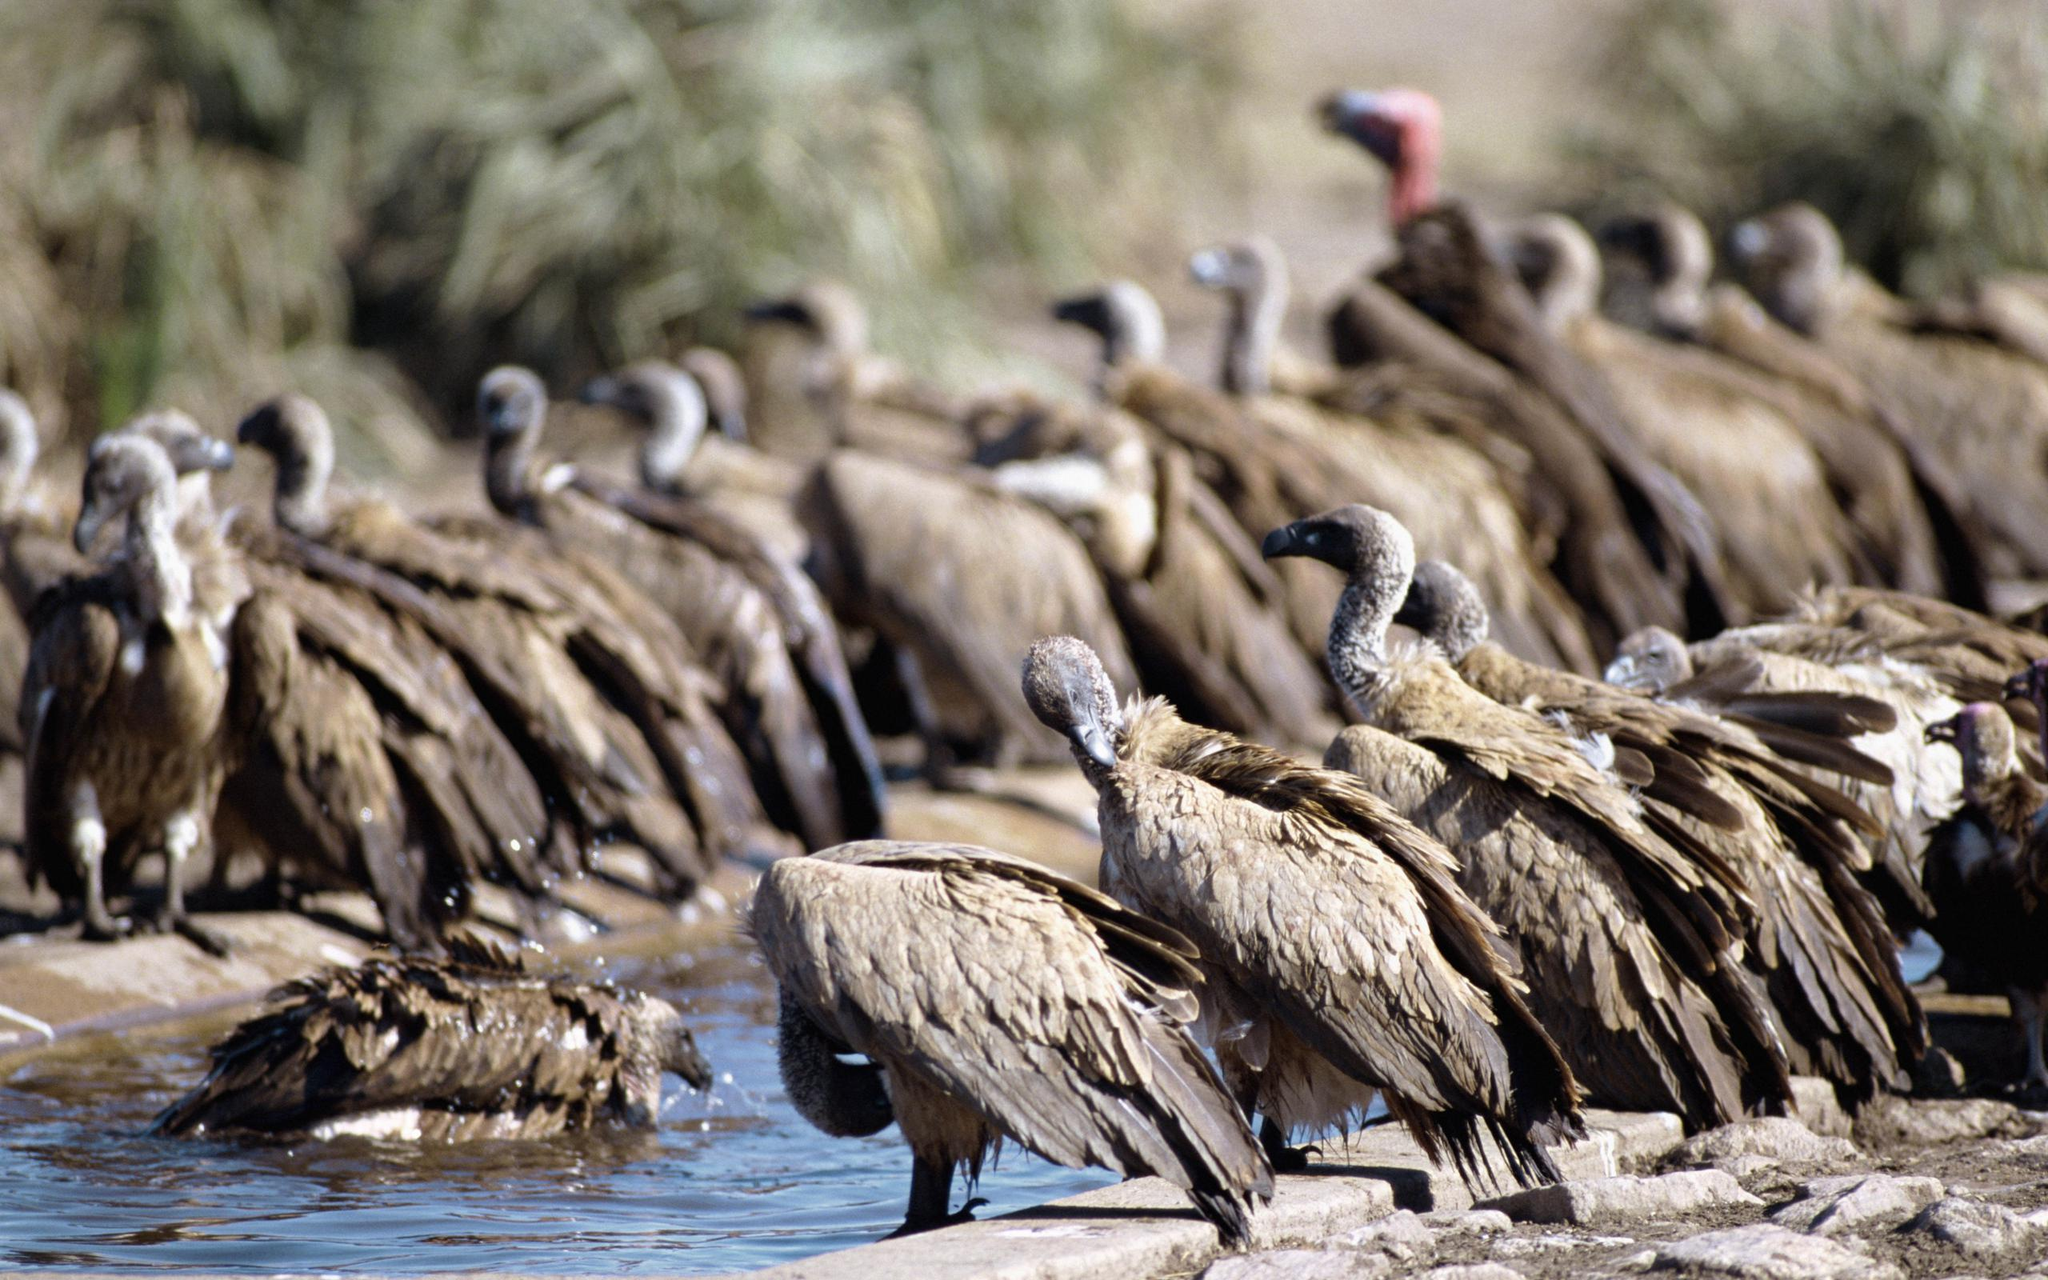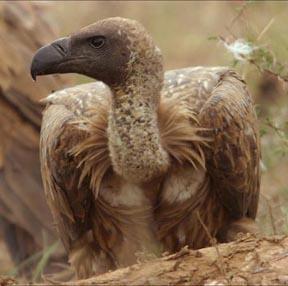The first image is the image on the left, the second image is the image on the right. For the images displayed, is the sentence "The left image has two birds while the right only has one." factually correct? Answer yes or no. No. The first image is the image on the left, the second image is the image on the right. Examine the images to the left and right. Is the description "In at least one image there is a closeup of a lone vultures face" accurate? Answer yes or no. Yes. 